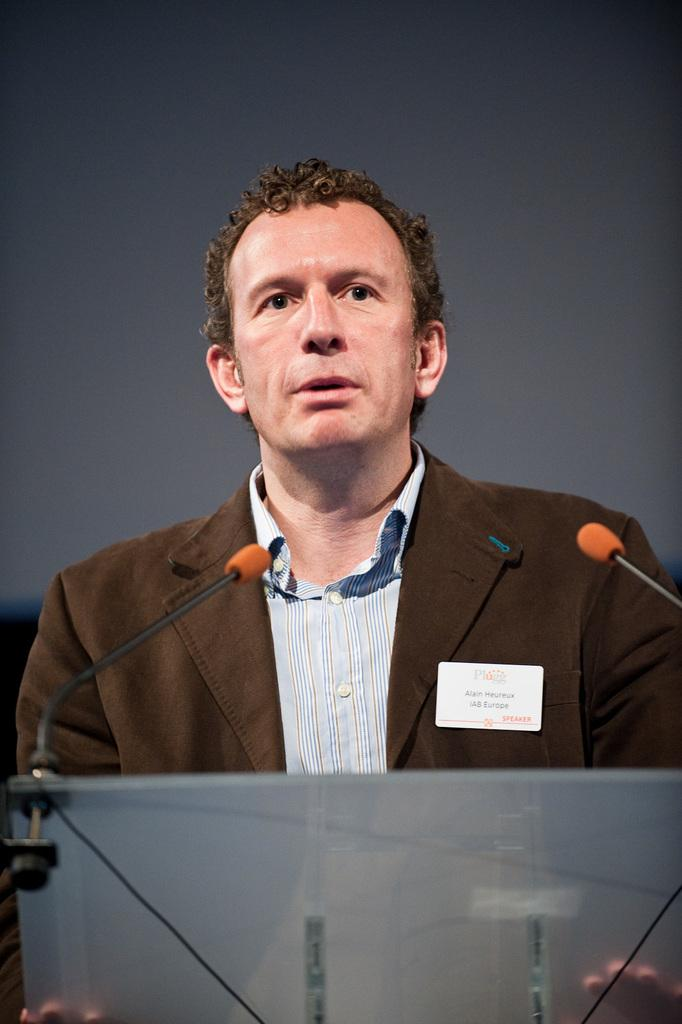What is located in the foreground of the image? There is a podium in the foreground of the image. What is the person in front of the podium doing? The person is standing and speaking in front of the podium. What can be seen in the center of the image? There are microphones in the center of the image. What color is the background of the image? The background of the image is black. What name is suggested on the list in the image? There is no list or name present in the image; it features a podium, a person speaking, microphones, and a black background. 